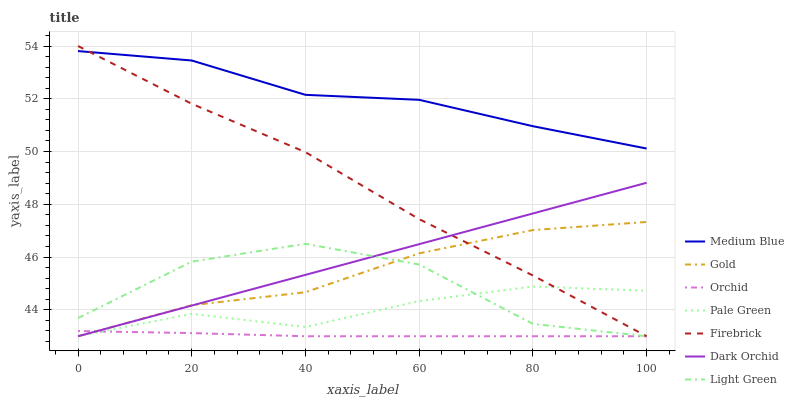Does Orchid have the minimum area under the curve?
Answer yes or no. Yes. Does Medium Blue have the maximum area under the curve?
Answer yes or no. Yes. Does Firebrick have the minimum area under the curve?
Answer yes or no. No. Does Firebrick have the maximum area under the curve?
Answer yes or no. No. Is Dark Orchid the smoothest?
Answer yes or no. Yes. Is Light Green the roughest?
Answer yes or no. Yes. Is Firebrick the smoothest?
Answer yes or no. No. Is Firebrick the roughest?
Answer yes or no. No. Does Gold have the lowest value?
Answer yes or no. Yes. Does Medium Blue have the lowest value?
Answer yes or no. No. Does Firebrick have the highest value?
Answer yes or no. Yes. Does Medium Blue have the highest value?
Answer yes or no. No. Is Gold less than Medium Blue?
Answer yes or no. Yes. Is Medium Blue greater than Pale Green?
Answer yes or no. Yes. Does Orchid intersect Light Green?
Answer yes or no. Yes. Is Orchid less than Light Green?
Answer yes or no. No. Is Orchid greater than Light Green?
Answer yes or no. No. Does Gold intersect Medium Blue?
Answer yes or no. No. 